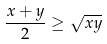<formula> <loc_0><loc_0><loc_500><loc_500>\frac { x + y } { 2 } \geq \sqrt { x y }</formula> 